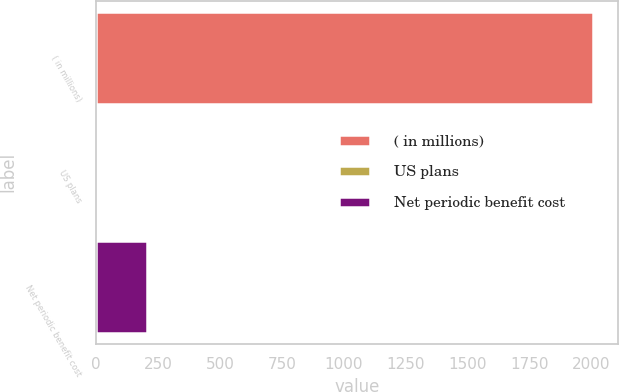Convert chart to OTSL. <chart><loc_0><loc_0><loc_500><loc_500><bar_chart><fcel>( in millions)<fcel>US plans<fcel>Net periodic benefit cost<nl><fcel>2006<fcel>6.5<fcel>206.45<nl></chart> 